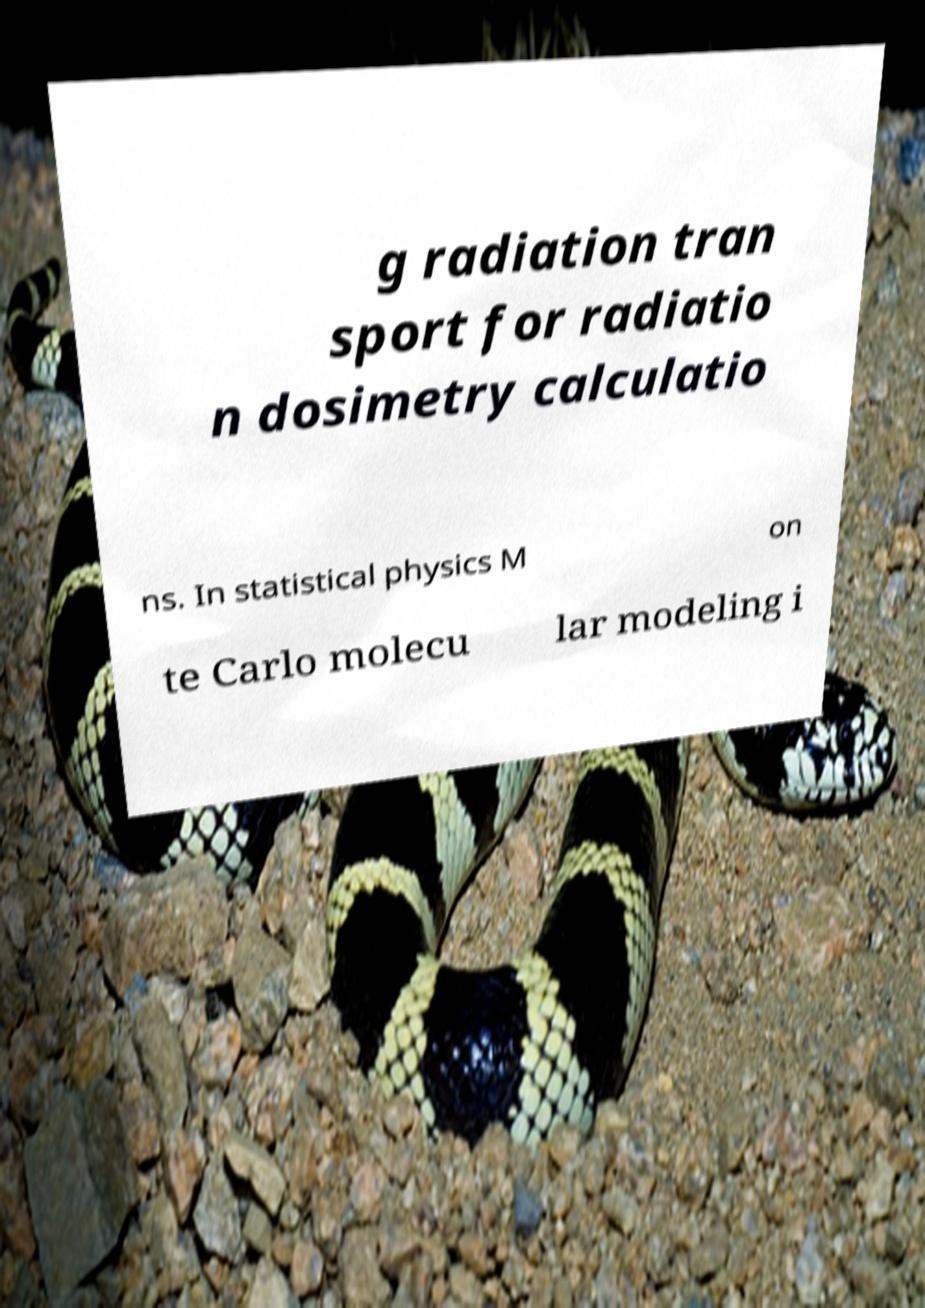What messages or text are displayed in this image? I need them in a readable, typed format. g radiation tran sport for radiatio n dosimetry calculatio ns. In statistical physics M on te Carlo molecu lar modeling i 